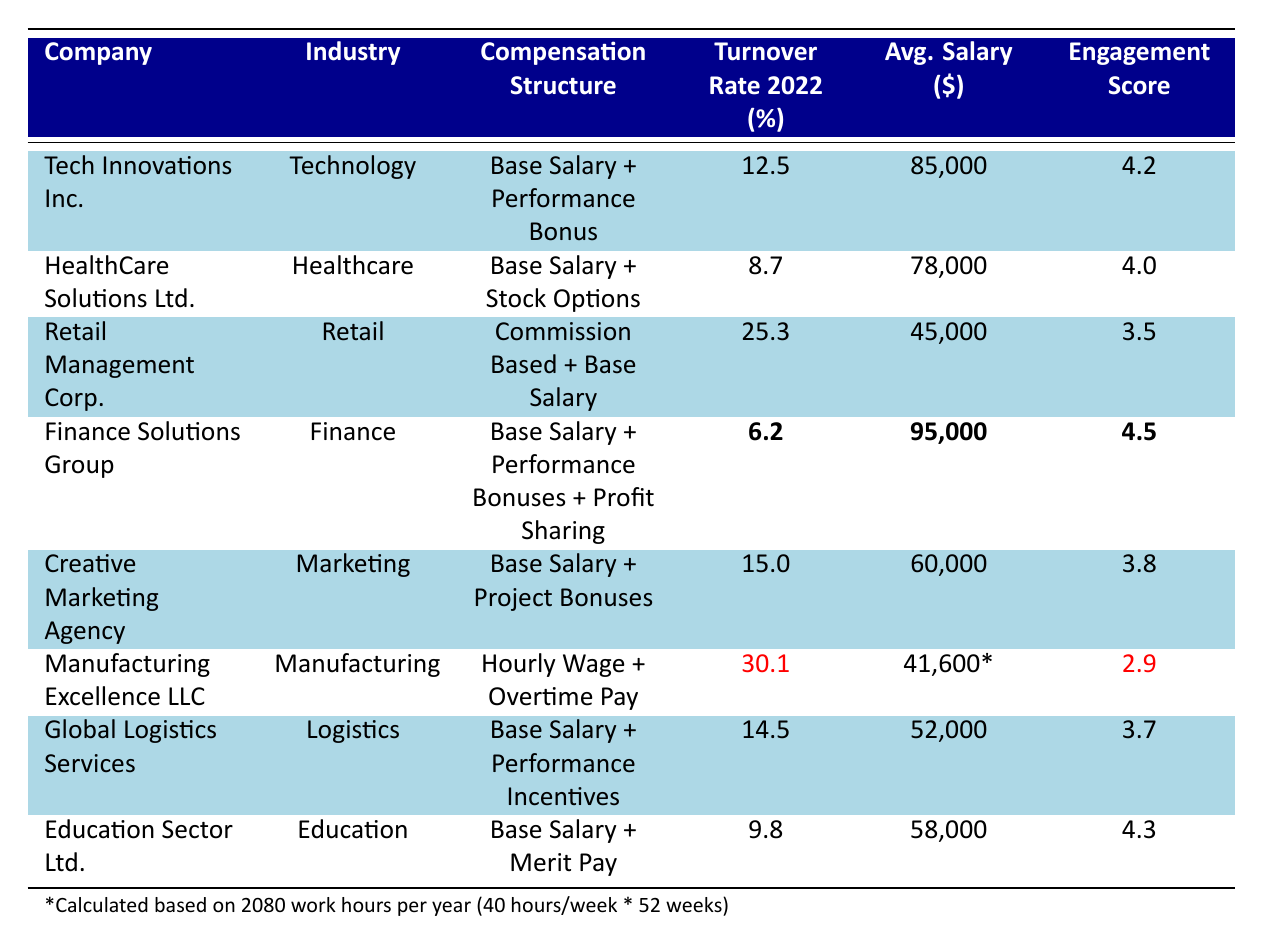What is the turnover rate for Finance Solutions Group? The table indicates the turnover rate for Finance Solutions Group in 2022 is listed as 6.2%.
Answer: 6.2% Which company has the highest employee engagement score? The employee engagement scores are 4.2 for Tech Innovations Inc., 4.0 for HealthCare Solutions Ltd., 3.5 for Retail Management Corp., 4.5 for Finance Solutions Group, 3.8 for Creative Marketing Agency, 2.9 for Manufacturing Excellence LLC, 3.7 for Global Logistics Services, and 4.3 for Education Sector Ltd. The highest is 4.5 for Finance Solutions Group.
Answer: Finance Solutions Group What is the average salary of employees at Retail Management Corp.? The average salary listed for Retail Management Corp. is $45,000.
Answer: $45,000 How many companies have a turnover rate greater than 15%? Observing the data, Retail Management Corp. has a turnover rate of 25.3% and Manufacturing Excellence LLC has 30.1%. Both are greater than 15%, so there are 2 companies.
Answer: 2 What is the average turnover rate of companies using a compensation structure that includes performance bonuses? The companies with performance bonuses are Tech Innovations Inc. (12.5%), Finance Solutions Group (6.2%), and Global Logistics Services (14.5%). Average calculation is (12.5 + 6.2 + 14.5) / 3 = 11.73%.
Answer: 11.73% Does HealthCare Solutions Ltd. have a lower turnover rate than Creative Marketing Agency? HealthCare Solutions Ltd. has a turnover rate of 8.7%, while Creative Marketing Agency has 15.0%. Since 8.7% is less than 15.0%, the statement is true.
Answer: Yes What is the difference between the average salary of Manufacturing Excellence LLC and Finance Solutions Group? Finance Solutions Group has an average salary of $95,000 and Manufacturing Excellence LLC has an average hourly wage of approximately $41,600 (calculated from $20/hour for 2080 hours). The difference is $95,000 - $41,600 = $53,400.
Answer: $53,400 Is there a correlation between the turnover rate and employee engagement score among the listed companies? The turnover rates and employee engagement scores suggest that companies with lower turnover rates tend to have higher engagement scores. For example, Finance Solutions Group with the lowest turnover (6.2%) has the highest engagement (4.5). This suggests a possible negative correlation overall but requires deeper analysis.
Answer: Yes (suggestive, requires analysis) Which industry has the lowest average salary? The average salaries listed are: Technology ($85,000), Healthcare ($78,000), Retail ($45,000), Finance ($95,000), Marketing ($60,000), Manufacturing ($41,600), Logistics ($52,000), Education ($58,000). The lowest is Manufacturing Excellence LLC at approximately $41,600.
Answer: Manufacturing What is the total average salary of the companies in the healthcare and education industries? Adding the average salaries for those companies: HealthCare Solutions Ltd. ($78,000) and Education Sector Ltd. ($58,000). So, the total is $78,000 + $58,000 = $136,000.
Answer: $136,000 